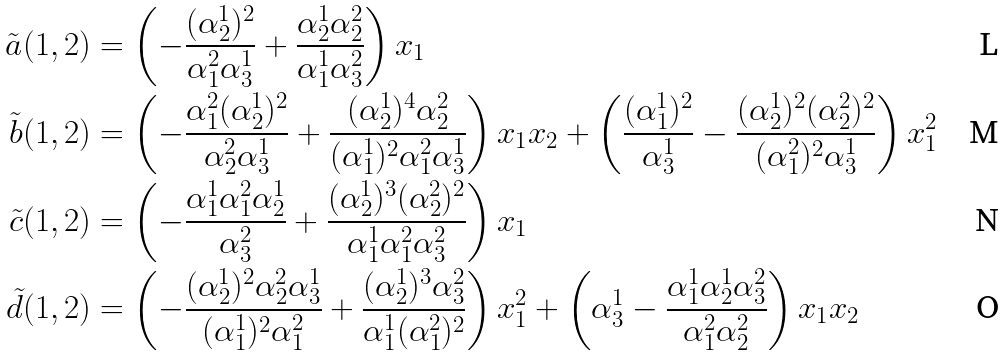Convert formula to latex. <formula><loc_0><loc_0><loc_500><loc_500>\tilde { a } ( 1 , 2 ) & = \left ( - \frac { ( \alpha _ { 2 } ^ { 1 } ) ^ { 2 } } { \alpha _ { 1 } ^ { 2 } \alpha _ { 3 } ^ { 1 } } + \frac { \alpha _ { 2 } ^ { 1 } \alpha _ { 2 } ^ { 2 } } { \alpha _ { 1 } ^ { 1 } \alpha _ { 3 } ^ { 2 } } \right ) x _ { 1 } \\ \tilde { b } ( 1 , 2 ) & = \left ( - \frac { \alpha _ { 1 } ^ { 2 } ( \alpha _ { 2 } ^ { 1 } ) ^ { 2 } } { \alpha _ { 2 } ^ { 2 } \alpha _ { 3 } ^ { 1 } } + \frac { ( \alpha _ { 2 } ^ { 1 } ) ^ { 4 } \alpha _ { 2 } ^ { 2 } } { ( \alpha _ { 1 } ^ { 1 } ) ^ { 2 } \alpha _ { 1 } ^ { 2 } \alpha _ { 3 } ^ { 1 } } \right ) x _ { 1 } x _ { 2 } + \left ( \frac { ( \alpha _ { 1 } ^ { 1 } ) ^ { 2 } } { \alpha _ { 3 } ^ { 1 } } - \frac { ( \alpha _ { 2 } ^ { 1 } ) ^ { 2 } ( \alpha _ { 2 } ^ { 2 } ) ^ { 2 } } { ( \alpha _ { 1 } ^ { 2 } ) ^ { 2 } \alpha _ { 3 } ^ { 1 } } \right ) x _ { 1 } ^ { 2 } \\ \tilde { c } ( 1 , 2 ) & = \left ( - \frac { \alpha _ { 1 } ^ { 1 } \alpha _ { 1 } ^ { 2 } \alpha _ { 2 } ^ { 1 } } { \alpha _ { 3 } ^ { 2 } } + \frac { ( \alpha _ { 2 } ^ { 1 } ) ^ { 3 } ( \alpha _ { 2 } ^ { 2 } ) ^ { 2 } } { \alpha _ { 1 } ^ { 1 } \alpha _ { 1 } ^ { 2 } \alpha _ { 3 } ^ { 2 } } \right ) x _ { 1 } \\ \tilde { d } ( 1 , 2 ) & = \left ( - \frac { ( \alpha _ { 2 } ^ { 1 } ) ^ { 2 } \alpha _ { 2 } ^ { 2 } \alpha _ { 3 } ^ { 1 } } { ( \alpha _ { 1 } ^ { 1 } ) ^ { 2 } \alpha _ { 1 } ^ { 2 } } + \frac { ( \alpha _ { 2 } ^ { 1 } ) ^ { 3 } \alpha _ { 3 } ^ { 2 } } { \alpha _ { 1 } ^ { 1 } ( \alpha _ { 1 } ^ { 2 } ) ^ { 2 } } \right ) x _ { 1 } ^ { 2 } + \left ( \alpha _ { 3 } ^ { 1 } - \frac { \alpha _ { 1 } ^ { 1 } \alpha _ { 2 } ^ { 1 } \alpha _ { 3 } ^ { 2 } } { \alpha _ { 1 } ^ { 2 } \alpha _ { 2 } ^ { 2 } } \right ) x _ { 1 } x _ { 2 }</formula> 